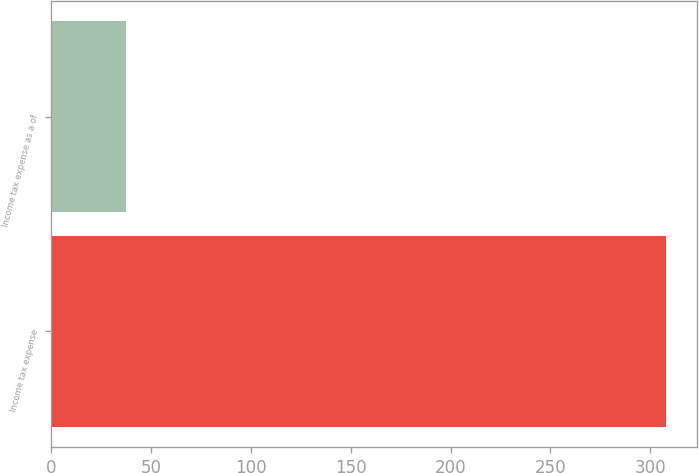<chart> <loc_0><loc_0><loc_500><loc_500><bar_chart><fcel>Income tax expense<fcel>Income tax expense as a of<nl><fcel>308<fcel>37.5<nl></chart> 